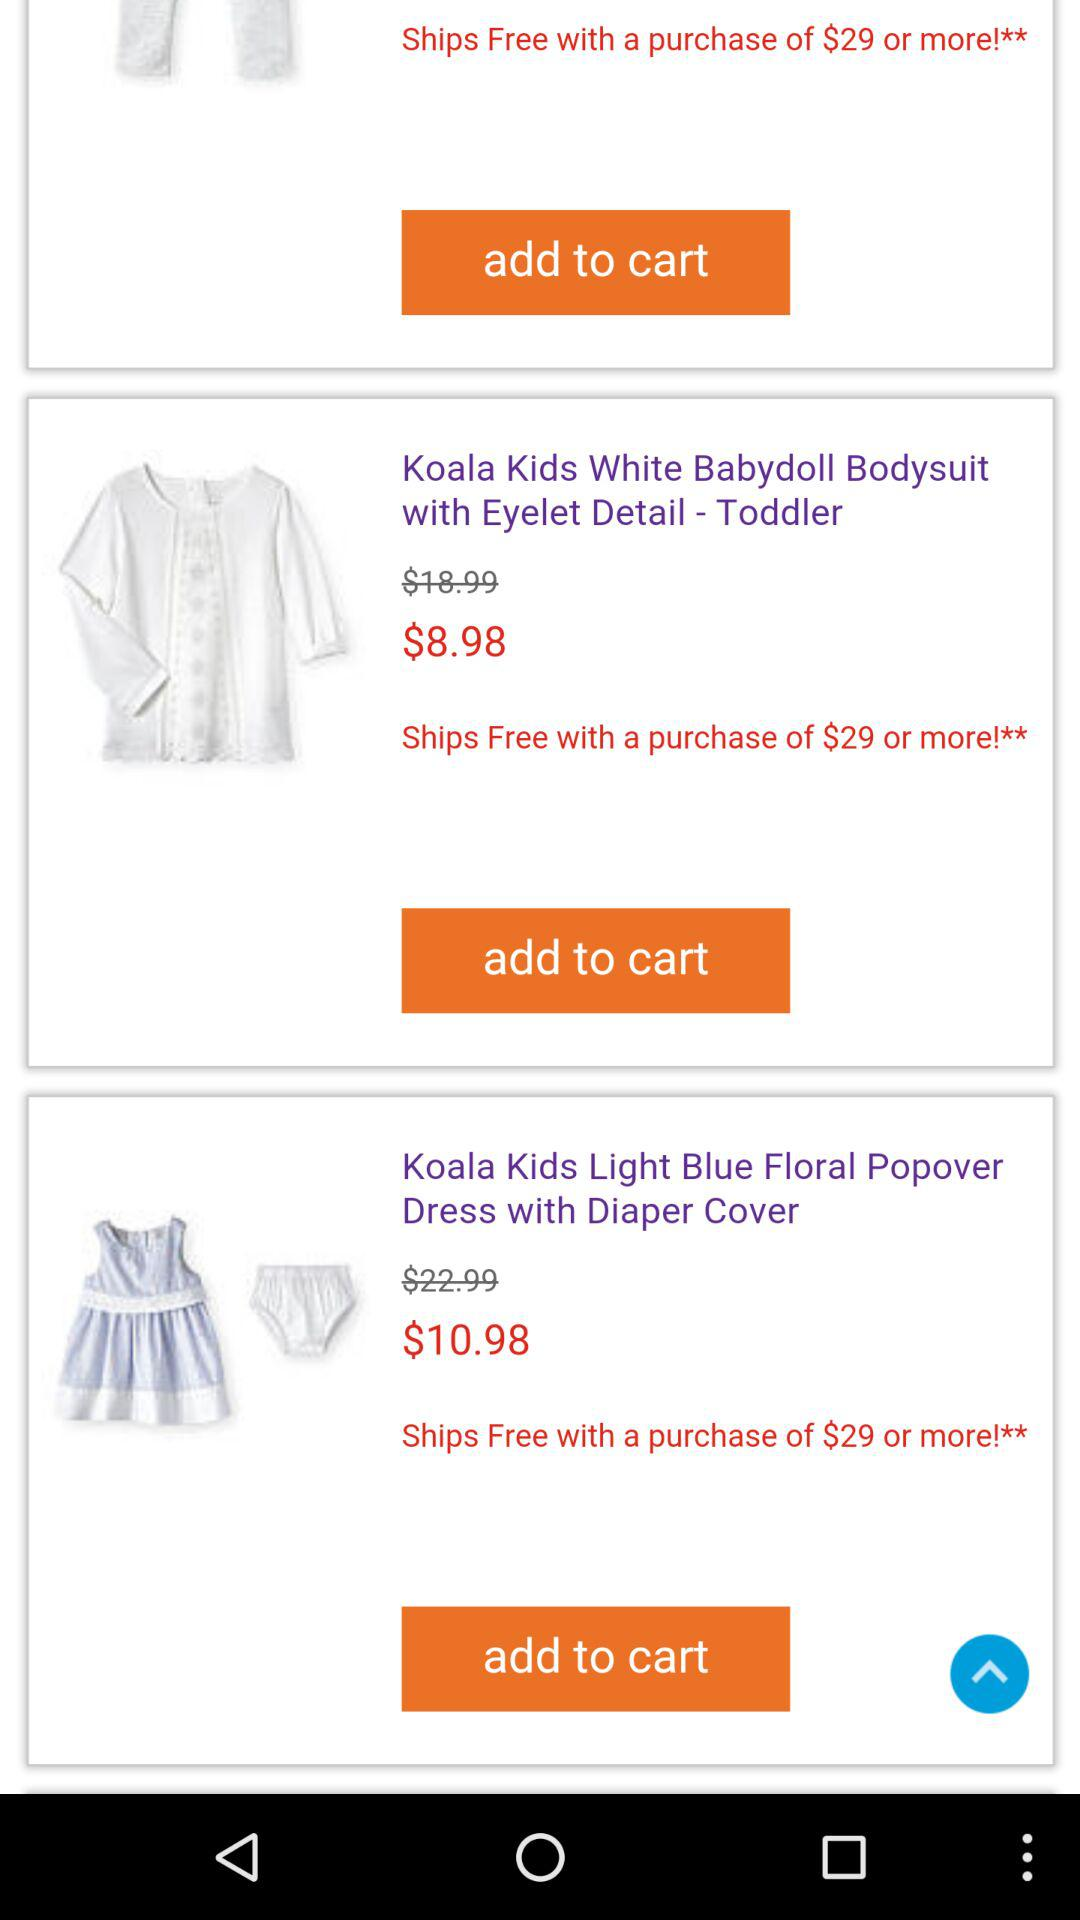What is the price of the "Babydoll Bodysuit" dress? The price of the "Babydoll Bodysuit" dress is $8.98. 